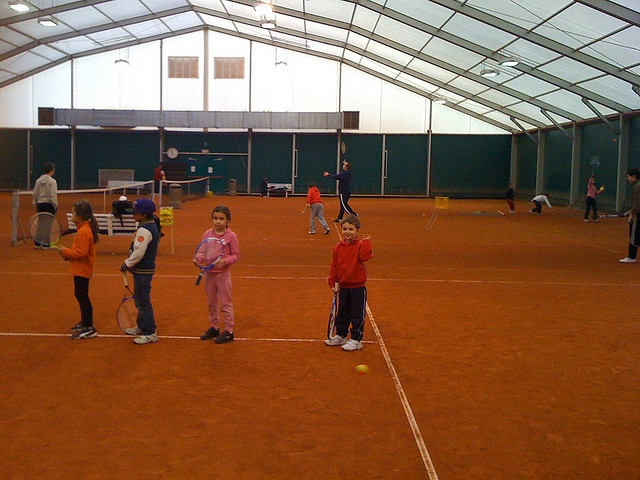Describe the objects in this image and their specific colors. I can see people in darkgray, brown, and maroon tones, people in darkgray, black, maroon, and brown tones, people in darkgray, black, maroon, gray, and tan tones, people in darkgray, black, maroon, and brown tones, and people in darkgray, maroon, black, and gray tones in this image. 